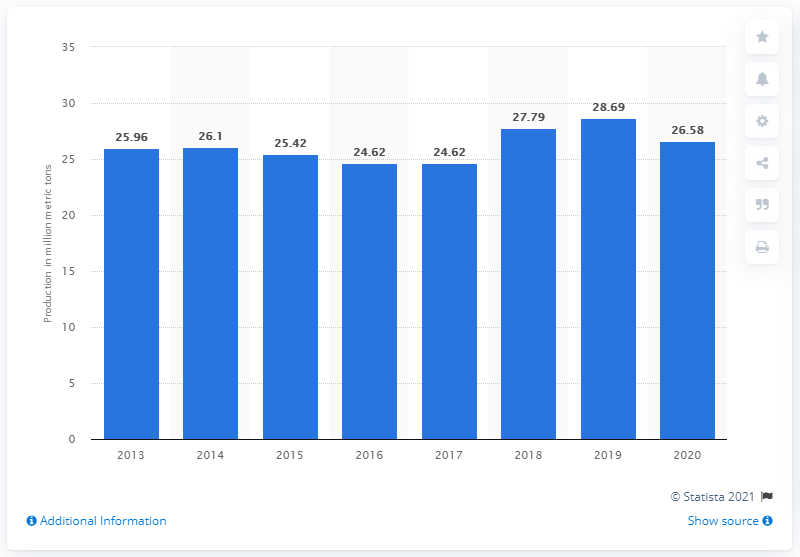Draw attention to some important aspects in this diagram. In 2020, a total of 26.58 million tonnes of liquefied natural gas was produced in Malaysia. 